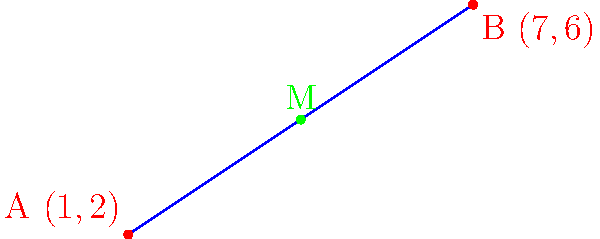During a town planning meeting, you're presented with a map showing two proposed locations for a new community center. Point A has coordinates (1,2) and Point B has coordinates (7,6). To ensure fair access, the center should be located at the midpoint of these two locations. What are the coordinates of this midpoint M? To find the midpoint M of a line segment AB, we can use the midpoint formula:

$$ M_x = \frac{x_1 + x_2}{2}, \quad M_y = \frac{y_1 + y_2}{2} $$

Where $(x_1, y_1)$ are the coordinates of point A and $(x_2, y_2)$ are the coordinates of point B.

Given:
- Point A: (1,2)
- Point B: (7,6)

Step 1: Calculate the x-coordinate of the midpoint:
$$ M_x = \frac{1 + 7}{2} = \frac{8}{2} = 4 $$

Step 2: Calculate the y-coordinate of the midpoint:
$$ M_y = \frac{2 + 6}{2} = \frac{8}{2} = 4 $$

Therefore, the coordinates of the midpoint M are (4,4).
Answer: (4,4) 